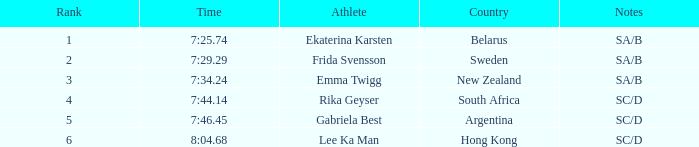What country is the athlete ekaterina karsten from with a rank less than 4? Belarus. 